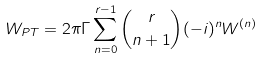Convert formula to latex. <formula><loc_0><loc_0><loc_500><loc_500>W _ { P T } = 2 \pi \Gamma \sum _ { n = 0 } ^ { r - 1 } \binom { r } { n + 1 } ( - i ) ^ { n } W ^ { ( n ) }</formula> 